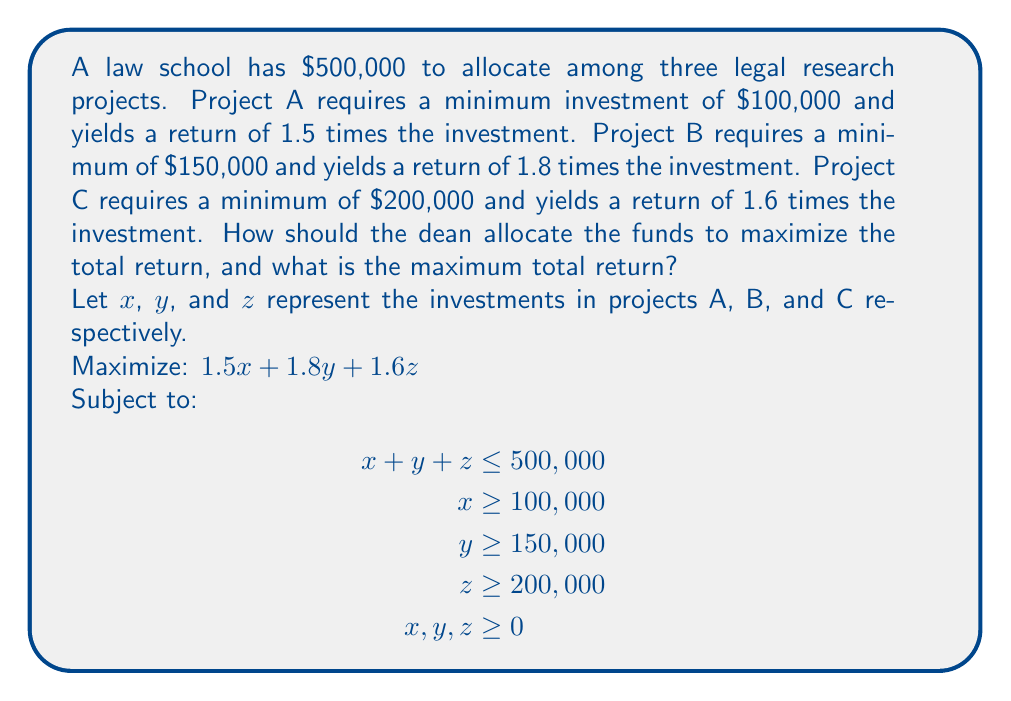Solve this math problem. To solve this linear programming problem, we'll use the simplex method:

1) First, we convert the inequality constraints to equality constraints by introducing slack variables:

   $$\begin{align}
   x + y + z + s_1 &= 500,000 \\
   x - s_2 &= 100,000 \\
   y - s_3 &= 150,000 \\
   z - s_4 &= 200,000
   \end{align}$$

2) Initial basic feasible solution:
   $x = 100,000$, $y = 150,000$, $z = 200,000$, $s_1 = 50,000$, $s_2 = s_3 = s_4 = 0$

3) Initial tableau:

   $$\begin{array}{c|cccccccc}
    & x & y & z & s_1 & s_2 & s_3 & s_4 & RHS \\
   \hline
   0 & 1 & 1 & 1 & 1 & 0 & 0 & 0 & 500,000 \\
   0 & 1 & 0 & 0 & 0 & -1 & 0 & 0 & 100,000 \\
   0 & 0 & 1 & 0 & 0 & 0 & -1 & 0 & 150,000 \\
   0 & 0 & 0 & 1 & 0 & 0 & 0 & -1 & 200,000 \\
   \hline
   z & -1.5 & -1.8 & -1.6 & 0 & 0 & 0 & 0 & 0
   \end{array}$$

4) The most negative coefficient in the objective row is -1.8, corresponding to y. We choose this as our pivot column.

5) After pivoting and iterating, we reach the optimal solution:

   $$\begin{array}{c|cccccccc}
    & x & y & z & s_1 & s_2 & s_3 & s_4 & RHS \\
   \hline
   1.8 & 0 & 1 & 0 & 0 & 0 & -1 & 0 & 350,000 \\
   1.5 & 1 & 0 & 0 & 0 & -1 & 0 & 0 & 100,000 \\
   1.6 & 0 & 0 & 1 & 0 & 0 & 0 & -1 & 50,000 \\
   0 & 0 & 0 & 0 & 1 & 1 & 1 & 1 & 0 \\
   \hline
   z & 0 & 0 & 0 & 0 & 1.5 & 1.8 & 1.6 & 830,000
   \end{array}$$

6) The optimal solution is:
   $x = 100,000$, $y = 350,000$, $z = 50,000$

7) The maximum total return is $830,000.
Answer: The dean should allocate $100,000 to Project A, $350,000 to Project B, and $50,000 to Project C. The maximum total return is $830,000. 